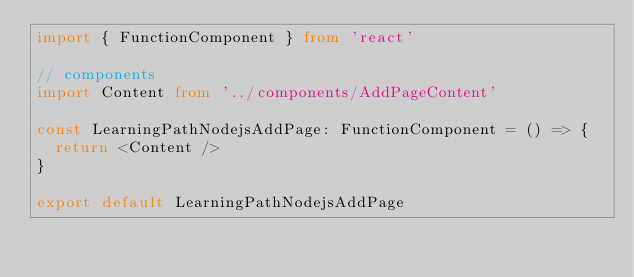<code> <loc_0><loc_0><loc_500><loc_500><_TypeScript_>import { FunctionComponent } from 'react'

// components
import Content from '../components/AddPageContent'

const LearningPathNodejsAddPage: FunctionComponent = () => {
  return <Content />
}

export default LearningPathNodejsAddPage
</code> 